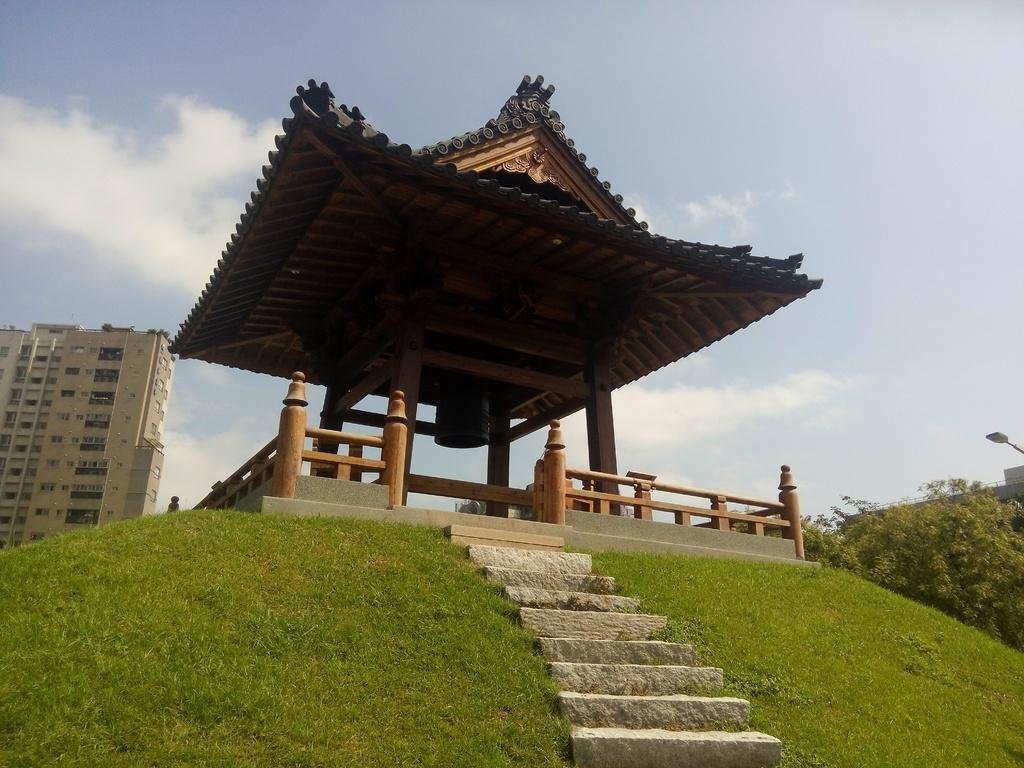What is the main structure in the image? There is a shrine in the image. What feature is present in front of the shrine? The shrine has steps in front of it. What type of terrain surrounds the shrine? The shrine is on a grassy area. What can be seen in the background of the image? There are plants and a building visible in the background of the image. What type of muscle is being exercised by the aunt on vacation in the image? There is no aunt or vacation present in the image, and therefore no muscle exercise can be observed. 